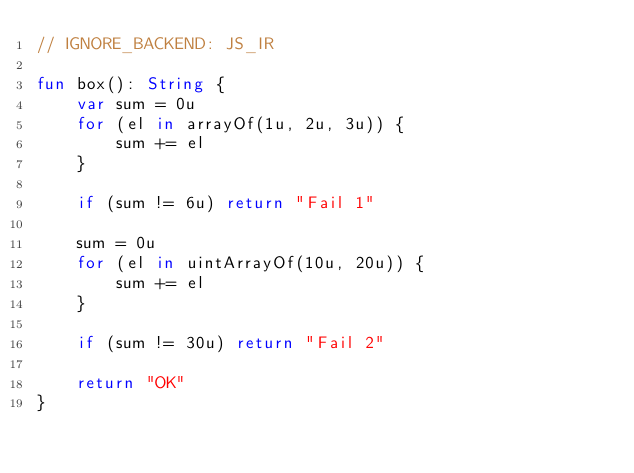<code> <loc_0><loc_0><loc_500><loc_500><_Kotlin_>// IGNORE_BACKEND: JS_IR

fun box(): String {
    var sum = 0u
    for (el in arrayOf(1u, 2u, 3u)) {
        sum += el
    }

    if (sum != 6u) return "Fail 1"

    sum = 0u
    for (el in uintArrayOf(10u, 20u)) {
        sum += el
    }

    if (sum != 30u) return "Fail 2"

    return "OK"
}</code> 